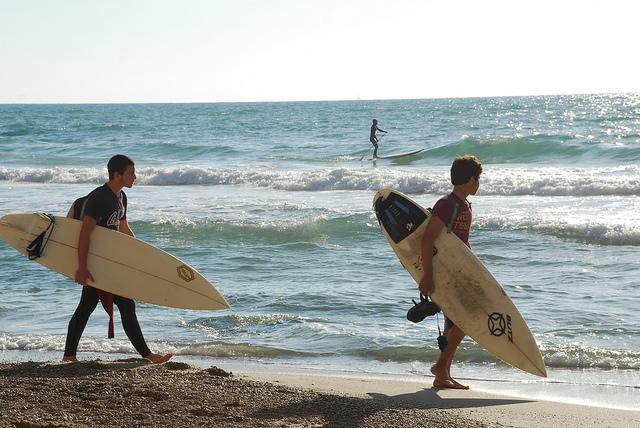Are they going surfing?
Be succinct. Yes. Do you see a sailboat in the picture?
Keep it brief. No. Do the people in this photo have shoes on?
Write a very short answer. No. 